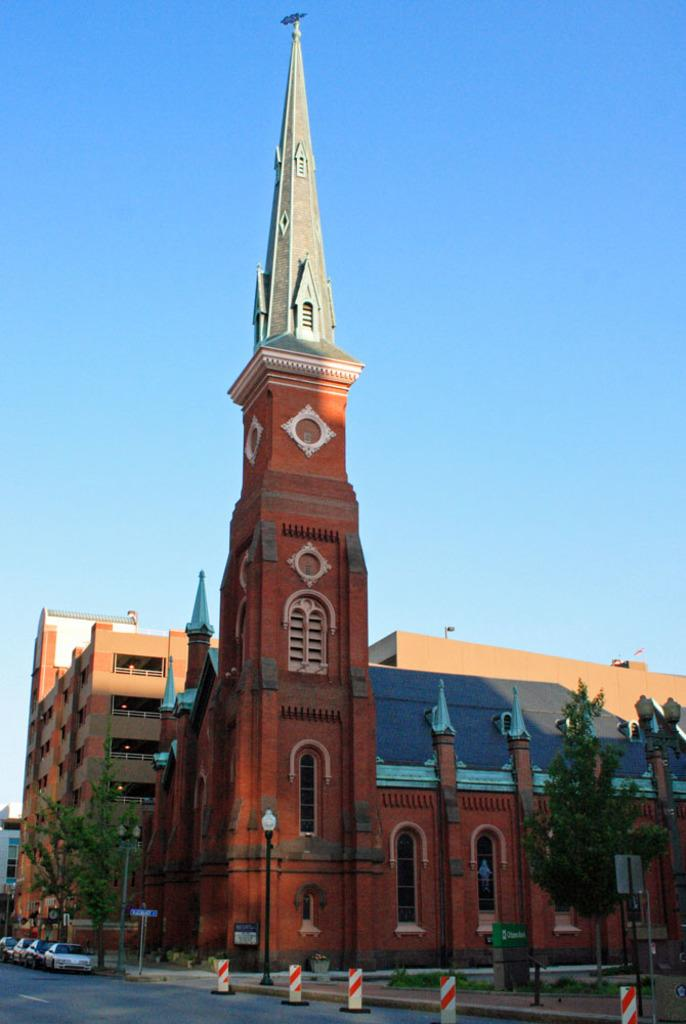What type of vehicles can be seen on the road in the image? There are cars on the road in the image. What structures are present in the image besides the cars? There are poles, boards, trees, a tower, and buildings in the image. What can be seen in the background of the image? The sky is visible in the background of the image. How much does the beggar charge for a ticket to the heat in the image? There is no beggar, ticket, or heat present in the image. 